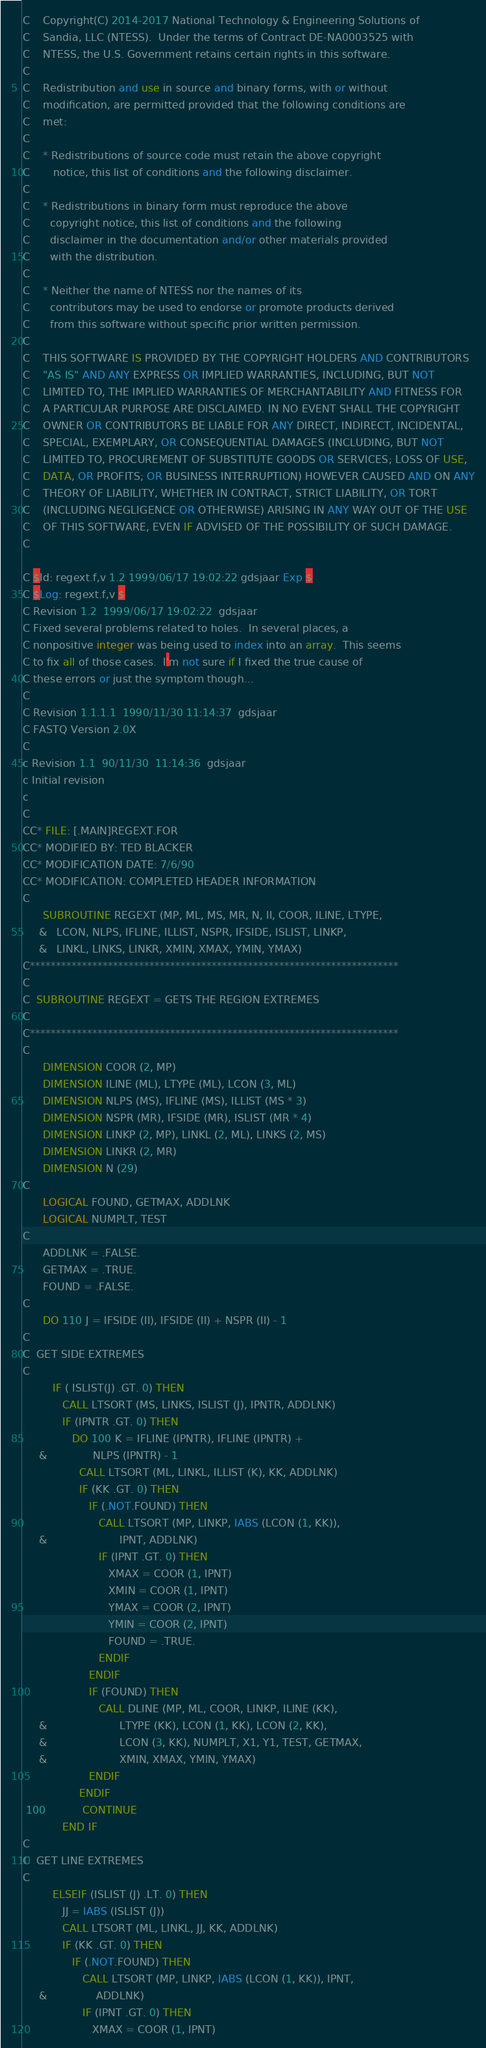Convert code to text. <code><loc_0><loc_0><loc_500><loc_500><_FORTRAN_>C    Copyright(C) 2014-2017 National Technology & Engineering Solutions of
C    Sandia, LLC (NTESS).  Under the terms of Contract DE-NA0003525 with
C    NTESS, the U.S. Government retains certain rights in this software.
C
C    Redistribution and use in source and binary forms, with or without
C    modification, are permitted provided that the following conditions are
C    met:
C
C    * Redistributions of source code must retain the above copyright
C       notice, this list of conditions and the following disclaimer.
C
C    * Redistributions in binary form must reproduce the above
C      copyright notice, this list of conditions and the following
C      disclaimer in the documentation and/or other materials provided
C      with the distribution.
C
C    * Neither the name of NTESS nor the names of its
C      contributors may be used to endorse or promote products derived
C      from this software without specific prior written permission.
C
C    THIS SOFTWARE IS PROVIDED BY THE COPYRIGHT HOLDERS AND CONTRIBUTORS
C    "AS IS" AND ANY EXPRESS OR IMPLIED WARRANTIES, INCLUDING, BUT NOT
C    LIMITED TO, THE IMPLIED WARRANTIES OF MERCHANTABILITY AND FITNESS FOR
C    A PARTICULAR PURPOSE ARE DISCLAIMED. IN NO EVENT SHALL THE COPYRIGHT
C    OWNER OR CONTRIBUTORS BE LIABLE FOR ANY DIRECT, INDIRECT, INCIDENTAL,
C    SPECIAL, EXEMPLARY, OR CONSEQUENTIAL DAMAGES (INCLUDING, BUT NOT
C    LIMITED TO, PROCUREMENT OF SUBSTITUTE GOODS OR SERVICES; LOSS OF USE,
C    DATA, OR PROFITS; OR BUSINESS INTERRUPTION) HOWEVER CAUSED AND ON ANY
C    THEORY OF LIABILITY, WHETHER IN CONTRACT, STRICT LIABILITY, OR TORT
C    (INCLUDING NEGLIGENCE OR OTHERWISE) ARISING IN ANY WAY OUT OF THE USE
C    OF THIS SOFTWARE, EVEN IF ADVISED OF THE POSSIBILITY OF SUCH DAMAGE.
C

C $Id: regext.f,v 1.2 1999/06/17 19:02:22 gdsjaar Exp $
C $Log: regext.f,v $
C Revision 1.2  1999/06/17 19:02:22  gdsjaar
C Fixed several problems related to holes.  In several places, a
C nonpositive integer was being used to index into an array.  This seems
C to fix all of those cases.  I'm not sure if I fixed the true cause of
C these errors or just the symptom though...
C
C Revision 1.1.1.1  1990/11/30 11:14:37  gdsjaar
C FASTQ Version 2.0X
C
c Revision 1.1  90/11/30  11:14:36  gdsjaar
c Initial revision
c
C
CC* FILE: [.MAIN]REGEXT.FOR
CC* MODIFIED BY: TED BLACKER
CC* MODIFICATION DATE: 7/6/90
CC* MODIFICATION: COMPLETED HEADER INFORMATION
C
      SUBROUTINE REGEXT (MP, ML, MS, MR, N, II, COOR, ILINE, LTYPE,
     &   LCON, NLPS, IFLINE, ILLIST, NSPR, IFSIDE, ISLIST, LINKP,
     &   LINKL, LINKS, LINKR, XMIN, XMAX, YMIN, YMAX)
C***********************************************************************
C
C  SUBROUTINE REGEXT = GETS THE REGION EXTREMES
C
C***********************************************************************
C
      DIMENSION COOR (2, MP)
      DIMENSION ILINE (ML), LTYPE (ML), LCON (3, ML)
      DIMENSION NLPS (MS), IFLINE (MS), ILLIST (MS * 3)
      DIMENSION NSPR (MR), IFSIDE (MR), ISLIST (MR * 4)
      DIMENSION LINKP (2, MP), LINKL (2, ML), LINKS (2, MS)
      DIMENSION LINKR (2, MR)
      DIMENSION N (29)
C
      LOGICAL FOUND, GETMAX, ADDLNK
      LOGICAL NUMPLT, TEST
C
      ADDLNK = .FALSE.
      GETMAX = .TRUE.
      FOUND = .FALSE.
C
      DO 110 J = IFSIDE (II), IFSIDE (II) + NSPR (II) - 1
C
C  GET SIDE EXTREMES
C
         IF ( ISLIST(J) .GT. 0) THEN
            CALL LTSORT (MS, LINKS, ISLIST (J), IPNTR, ADDLNK)
            IF (IPNTR .GT. 0) THEN
               DO 100 K = IFLINE (IPNTR), IFLINE (IPNTR) +
     &              NLPS (IPNTR) - 1
                 CALL LTSORT (ML, LINKL, ILLIST (K), KK, ADDLNK)
                 IF (KK .GT. 0) THEN
                    IF (.NOT.FOUND) THEN
                       CALL LTSORT (MP, LINKP, IABS (LCON (1, KK)),
     &                      IPNT, ADDLNK)
                       IF (IPNT .GT. 0) THEN
                          XMAX = COOR (1, IPNT)
                          XMIN = COOR (1, IPNT)
                          YMAX = COOR (2, IPNT)
                          YMIN = COOR (2, IPNT)
                          FOUND = .TRUE.
                       ENDIF
                    ENDIF
                    IF (FOUND) THEN
                       CALL DLINE (MP, ML, COOR, LINKP, ILINE (KK),
     &                      LTYPE (KK), LCON (1, KK), LCON (2, KK),
     &                      LCON (3, KK), NUMPLT, X1, Y1, TEST, GETMAX,
     &                      XMIN, XMAX, YMIN, YMAX)
                    ENDIF
                 ENDIF
 100           CONTINUE
            END IF
C
C  GET LINE EXTREMES
C
         ELSEIF (ISLIST (J) .LT. 0) THEN
            JJ = IABS (ISLIST (J))
            CALL LTSORT (ML, LINKL, JJ, KK, ADDLNK)
            IF (KK .GT. 0) THEN
               IF (.NOT.FOUND) THEN
                  CALL LTSORT (MP, LINKP, IABS (LCON (1, KK)), IPNT,
     &               ADDLNK)
                  IF (IPNT .GT. 0) THEN
                     XMAX = COOR (1, IPNT)</code> 